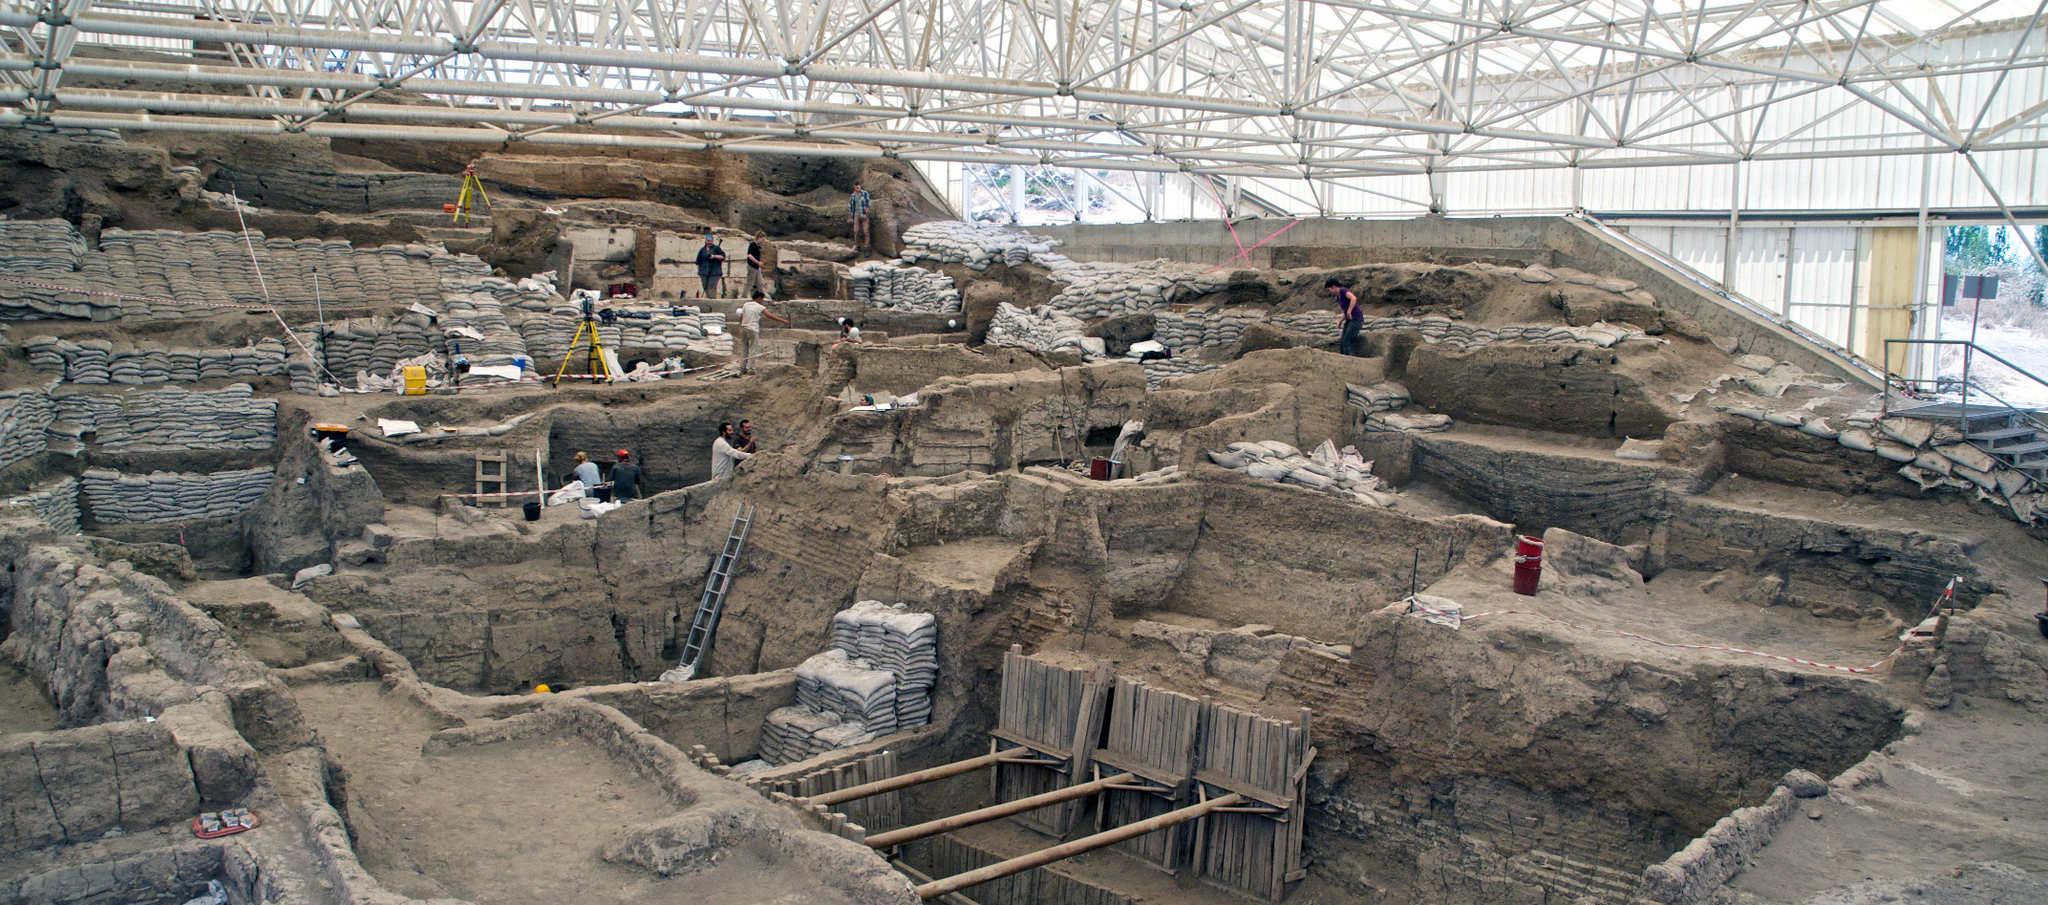Write a detailed description of the given image.
 This image captures the archaeological site of Catalhoyuk in Turkey, one of the world's oldest known human settlements. The perspective is from a high angle, providing a comprehensive view of the ongoing excavation. The site is sheltered under a large white roof, protecting the ancient ruins and the archaeologists at work. 

Beneath the roof, the remnants of the ancient settlement are visible. These ruins are characterized by multiple layers of walls and structures, revealing the complex architecture of the past. Wooden scaffolding is erected in certain areas, aiding in the careful exploration of this historical site.

The color palette of the image is dominated by shades of gray and brown, reflecting the earthy tones of the archaeological site. However, the workers' clothing and equipment introduce splashes of yellow and red, adding a touch of vibrancy to the scene. 

Overall, the image provides a fascinating glimpse into the past, showcasing the meticulous process of unearthing history at Catalhoyuk. 